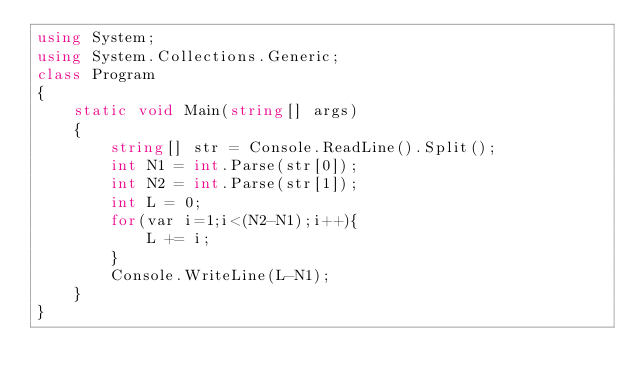Convert code to text. <code><loc_0><loc_0><loc_500><loc_500><_C#_>using System;
using System.Collections.Generic;
class Program
{
	static void Main(string[] args)
	{
		string[] str = Console.ReadLine().Split();
		int N1 = int.Parse(str[0]);
		int N2 = int.Parse(str[1]);
		int L = 0;
		for(var i=1;i<(N2-N1);i++){
			L += i;
		}
		Console.WriteLine(L-N1);
	}
}</code> 